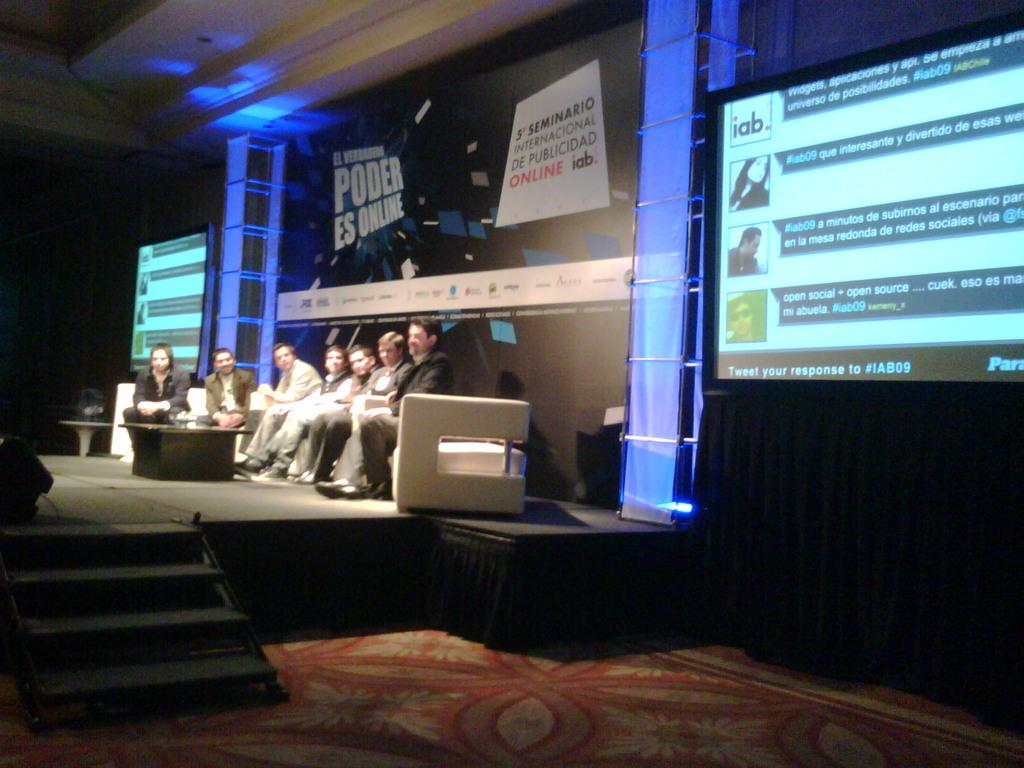What are the people in the image doing? The persons in the image are sitting on the sofa. What other objects can be seen in the image? There is a table, a pillar, a screen, and a banner in the background. What is the floor like in the image? The image shows a floor. What type of stone is being used for the selection process in the image? There is no mention of a selection process or stone in the image. 